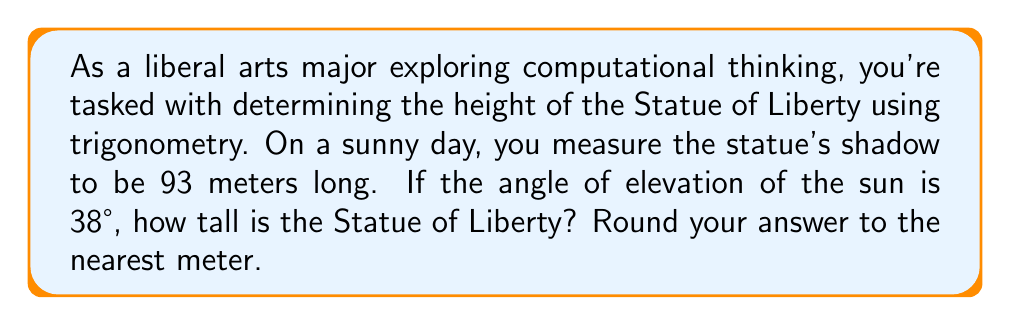Teach me how to tackle this problem. Let's approach this step-by-step using trigonometry:

1) First, we need to visualize the problem. We have a right triangle where:
   - The statue's height is the opposite side
   - The shadow length is the adjacent side
   - The angle of elevation of the sun is the angle between the adjacent side and the hypotenuse

2) We can represent this situation with the following diagram:

[asy]
import geometry;

size(200);
pair A = (0,0), B = (10,0), C = (0,7.5);
draw(A--B--C--A);
draw(rightangle(A,B,C,20));
label("93 m", (A--B), S);
label("Height", (A--C), W);
label("38°", A, SE);
[/asy]

3) In this right triangle, we know:
   - The adjacent side (shadow length) = 93 meters
   - The angle of elevation = 38°

4) We need to find the opposite side (statue's height). The trigonometric ratio that relates the opposite side to the adjacent side is the tangent function.

5) The formula for tangent in this case is:

   $$\tan(38°) = \frac{\text{opposite}}{\text{adjacent}} = \frac{\text{height}}{93}$$

6) We can rearrange this to solve for height:

   $$\text{height} = 93 \times \tan(38°)$$

7) Now, let's calculate:
   $$\text{height} = 93 \times \tan(38°) \approx 93 \times 0.7813 \approx 72.66$$

8) Rounding to the nearest meter, we get 73 meters.
Answer: 73 meters 